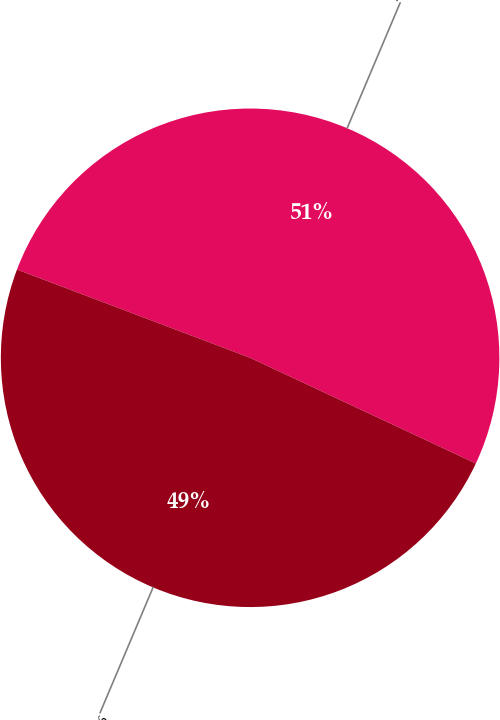<chart> <loc_0><loc_0><loc_500><loc_500><pie_chart><fcel>2007<fcel>2006<nl><fcel>51.21%<fcel>48.79%<nl></chart> 